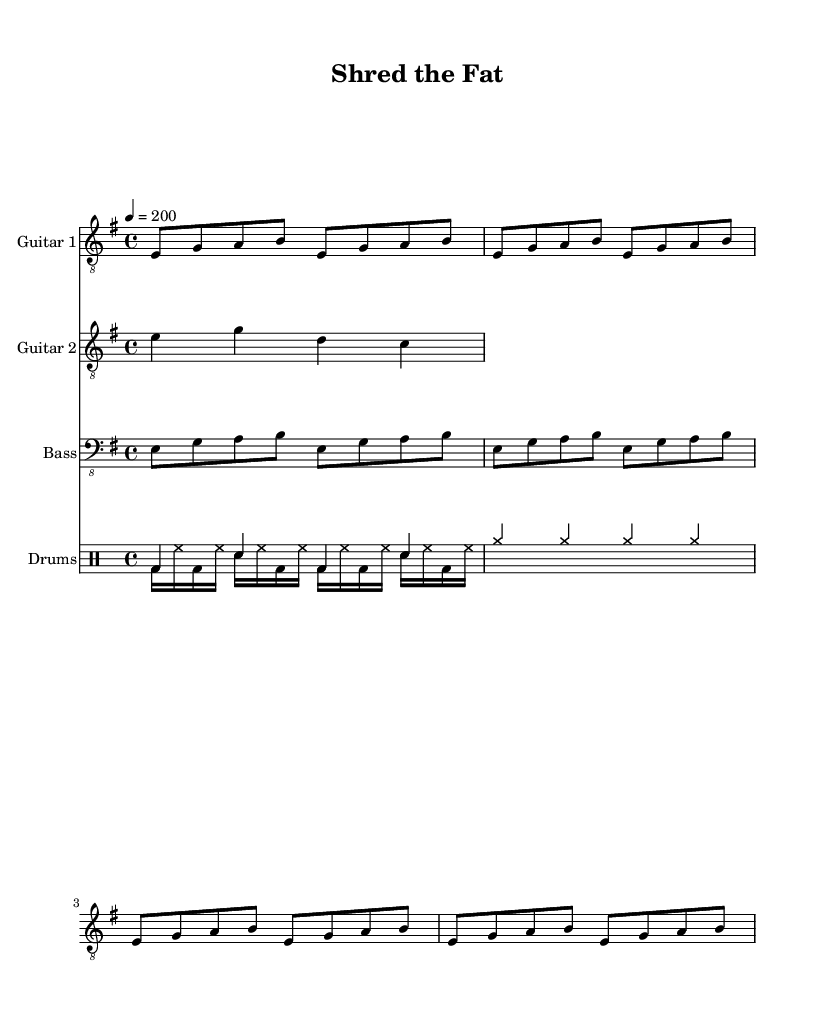What is the key signature of this music? The key signature is E minor, which has one sharp (F#) and is indicated at the beginning of the staff.
Answer: E minor What is the time signature of this music? The time signature is 4/4, which means there are four beats in each measure and the quarter note gets one beat. This is clearly indicated at the start of the piece.
Answer: 4/4 What is the tempo marking for this piece? The tempo marking is indicated as 4 = 200, meaning the piece should be played at a brisk speed of 200 beats per minute. This is typically located at the beginning of the score.
Answer: 200 How many measures are in the guitar part? The guitar part has 8 measures as it contains two repetitions of the initial phrase, which lasts for 4 measures each. This can be counted by identifying the sections between the bar lines.
Answer: 8 What type of rhythm does the drum section primarily use? The drum section primarily uses a combination of bass drum and snare patterns with occasional cymbal crashes, which is characteristic of energetic thrash metal to maintain a high intensity during performance.
Answer: Energetic rhythms What are the instruments used in this composition? The composition features two guitars, a bass, and drums, as indicated by the labels at the start of each staff in the score.
Answer: Two guitars, bass, drums Which scale do the guitar parts primarily utilize? The guitar parts primarily utilize the E minor scale, as evident from the notes played in both guitar parts that correspond to the notes in the E minor scale (E, G, A, B).
Answer: E minor scale 